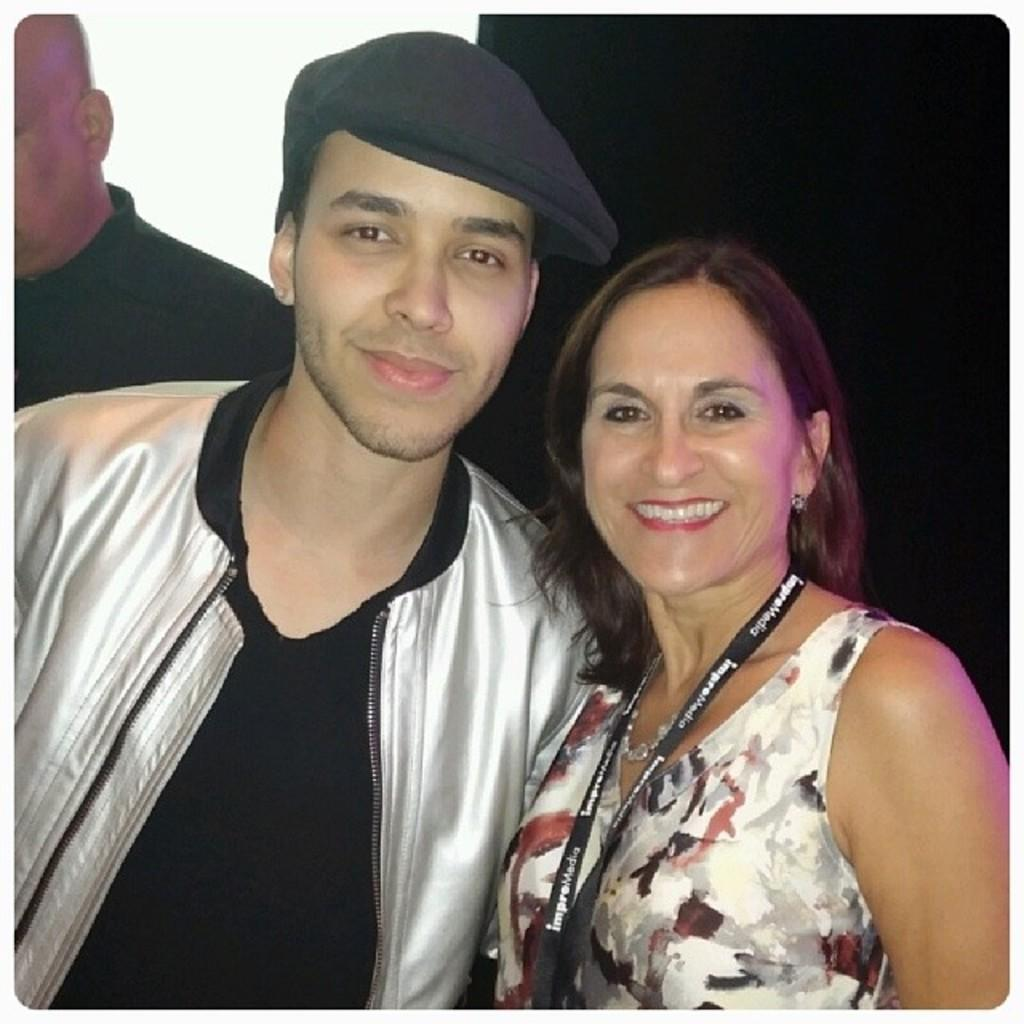What are the two persons in the foreground of the image doing? The two persons in the foreground of the image are standing and smiling. Can you describe the person in the background of the image? There is another person standing in the background of the image. What type of button is being used to drain the water in the image? There is no button or water present in the image; it features two persons standing and smiling in the foreground and another person standing in the background. 